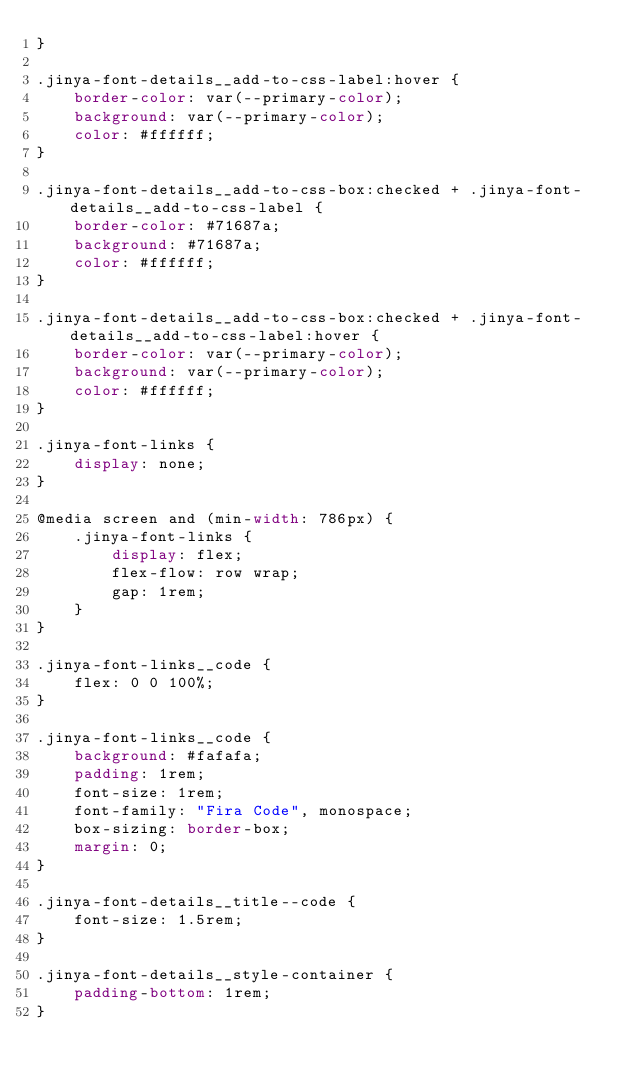<code> <loc_0><loc_0><loc_500><loc_500><_CSS_>}

.jinya-font-details__add-to-css-label:hover {
    border-color: var(--primary-color);
    background: var(--primary-color);
    color: #ffffff;
}

.jinya-font-details__add-to-css-box:checked + .jinya-font-details__add-to-css-label {
    border-color: #71687a;
    background: #71687a;
    color: #ffffff;
}

.jinya-font-details__add-to-css-box:checked + .jinya-font-details__add-to-css-label:hover {
    border-color: var(--primary-color);
    background: var(--primary-color);
    color: #ffffff;
}

.jinya-font-links {
    display: none;
}

@media screen and (min-width: 786px) {
    .jinya-font-links {
        display: flex;
        flex-flow: row wrap;
        gap: 1rem;
    }
}

.jinya-font-links__code {
    flex: 0 0 100%;
}

.jinya-font-links__code {
    background: #fafafa;
    padding: 1rem;
    font-size: 1rem;
    font-family: "Fira Code", monospace;
    box-sizing: border-box;
    margin: 0;
}

.jinya-font-details__title--code {
    font-size: 1.5rem;
}

.jinya-font-details__style-container {
    padding-bottom: 1rem;
}
</code> 